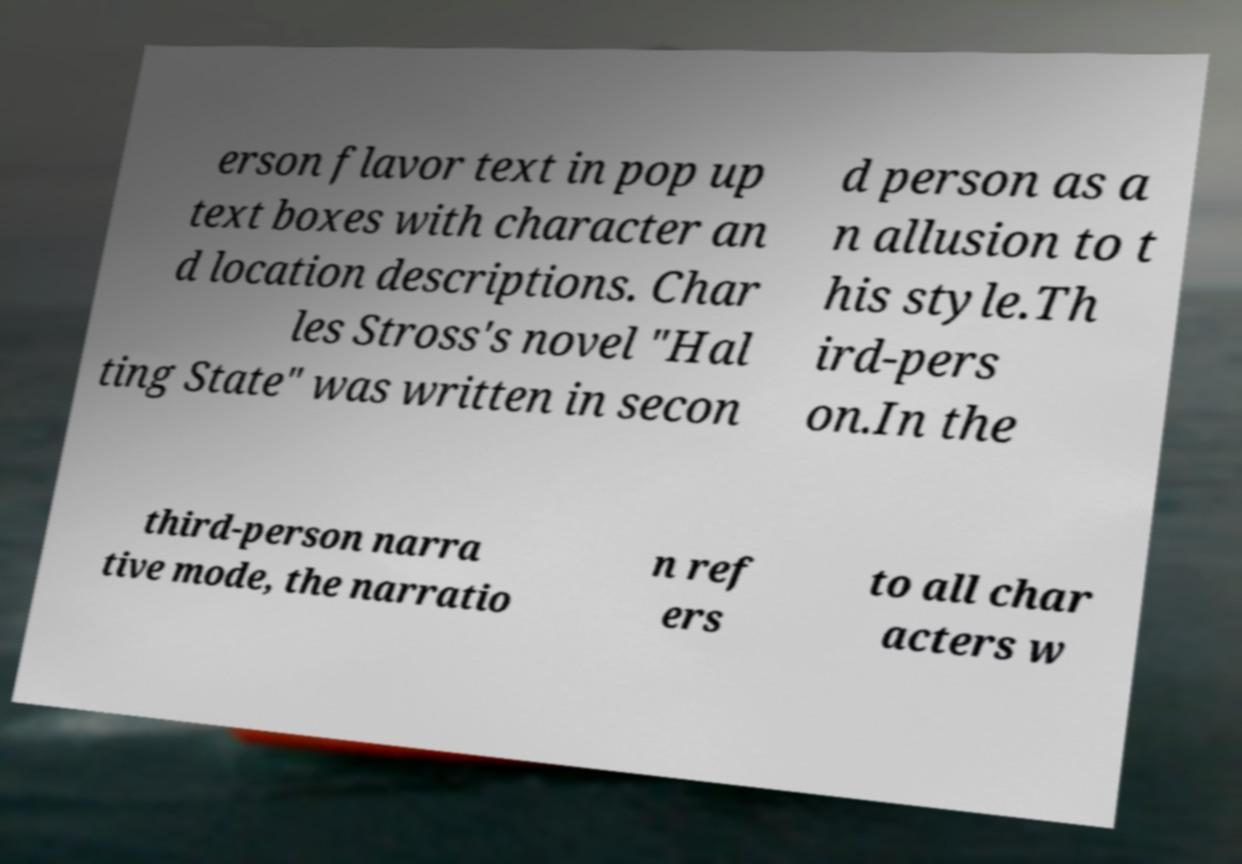Can you read and provide the text displayed in the image?This photo seems to have some interesting text. Can you extract and type it out for me? erson flavor text in pop up text boxes with character an d location descriptions. Char les Stross's novel "Hal ting State" was written in secon d person as a n allusion to t his style.Th ird-pers on.In the third-person narra tive mode, the narratio n ref ers to all char acters w 